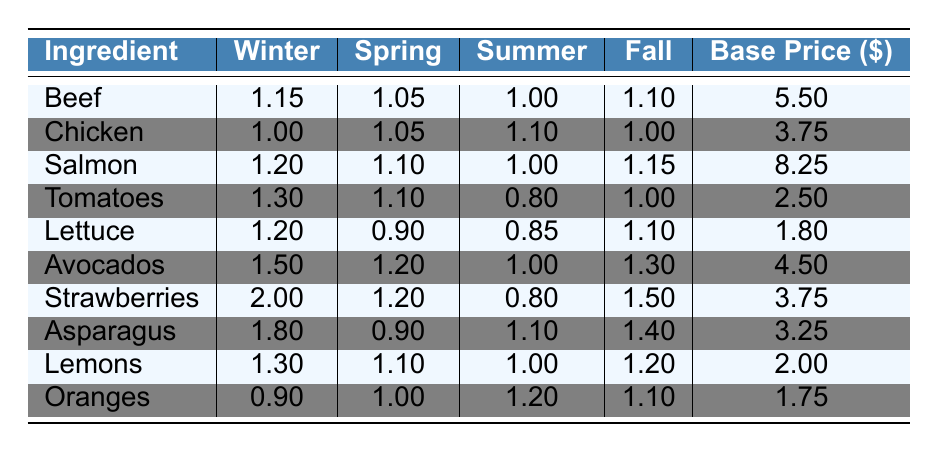What is the price fluctuation of Beef in Spring? From the table, Beef's price fluctuation in Spring is listed directly under the Spring column, which shows a value of 1.05.
Answer: 1.05 What is the base price of Tomatoes? Looking at the table, the base price of Tomatoes is found in the last column, presenting a value of 2.50.
Answer: 2.50 Which ingredient has the highest price fluctuation in Winter? By inspecting the Winter column, we see the prices listed for each ingredient. The highest value is for Strawberries, which is 2.00.
Answer: Strawberries How does the price fluctuation of Avocados in Summer compare to that in Fall? Avocados' price fluctuation in Summer is 1.00 and in Fall is 1.30. Since 1.30 is greater than 1.00, it shows that Avocados are more expensive in Fall than in Summer.
Answer: Higher in Fall Which ingredient shows the smallest price fluctuation in Summer? In the Summer column, the smallest value appears for Tomatoes at 0.80, indicating that this ingredient has the least fluctuation during Summer.
Answer: Tomatoes What is the average price fluctuation of Chicken across all seasons? The price fluctuations for Chicken across seasons are: Winter 1.00, Spring 1.05, Summer 1.10, and Fall 1.00. Averaging these gives: (1.00 + 1.05 + 1.10 + 1.00) / 4 = 1.0375.
Answer: 1.0375 Is there any season where Lettuce has a price fluctuation lower than 1.00? Checking the price fluctuations for Lettuce, we see the values are: Winter 1.20, Spring 0.90, Summer 0.85, and Fall 1.10. The values for Spring and Summer are both below 1.00.
Answer: Yes What is the difference in price fluctuation for Lemons between Winter and Fall? Lemons' price fluctuation in Winter is 1.30 and in Fall it is 1.20. The difference is calculated by subtracting: 1.30 - 1.20 = 0.10.
Answer: 0.10 Which ingredient has the highest base price among all listed? The base prices of the ingredients are: Beef 5.50, Chicken 3.75, Salmon 8.25, Tomatoes 2.50, Lettuce 1.80, Avocados 4.50, Strawberries 3.75, Asparagus 3.25, Lemons 2.00, and Oranges 1.75. The highest is for Salmon at 8.25.
Answer: Salmon If the price fluctuation of Asparagus remains the same, what would be the total cost for Winter and Spring? The price fluctuations for Asparagus are 1.80 in Winter and 0.90 in Spring. The total can be calculated as 1.80 + 0.90 = 2.70. Therefore, the total cost for Asparagus for both seasons is 2.70 when considering just the fluctuations.
Answer: 2.70 In which season is the price fluctuation of Strawberries at its lowest? Looking at the table, the price fluctuations for Strawberries show values of 2.00 in Winter, 1.20 in Spring, 0.80 in Summer, and 1.50 in Fall. The lowest value occurs in Summer.
Answer: Summer 